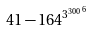Convert formula to latex. <formula><loc_0><loc_0><loc_500><loc_500>4 1 - 1 6 4 ^ { { 3 ^ { 3 0 0 } } ^ { 6 } }</formula> 